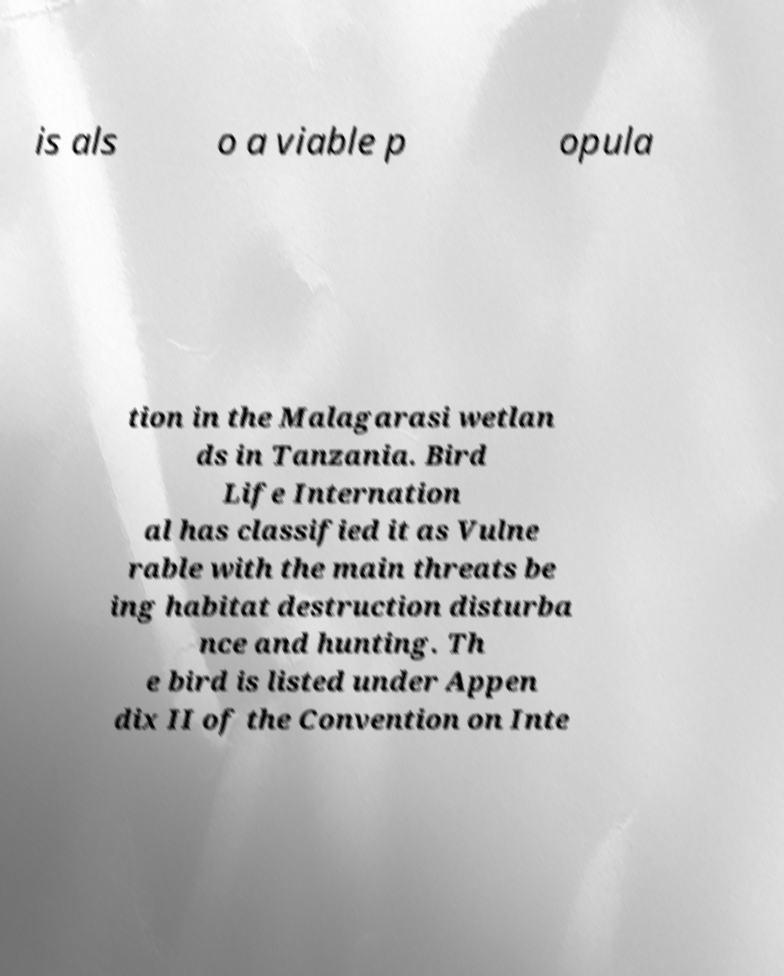Can you accurately transcribe the text from the provided image for me? is als o a viable p opula tion in the Malagarasi wetlan ds in Tanzania. Bird Life Internation al has classified it as Vulne rable with the main threats be ing habitat destruction disturba nce and hunting. Th e bird is listed under Appen dix II of the Convention on Inte 